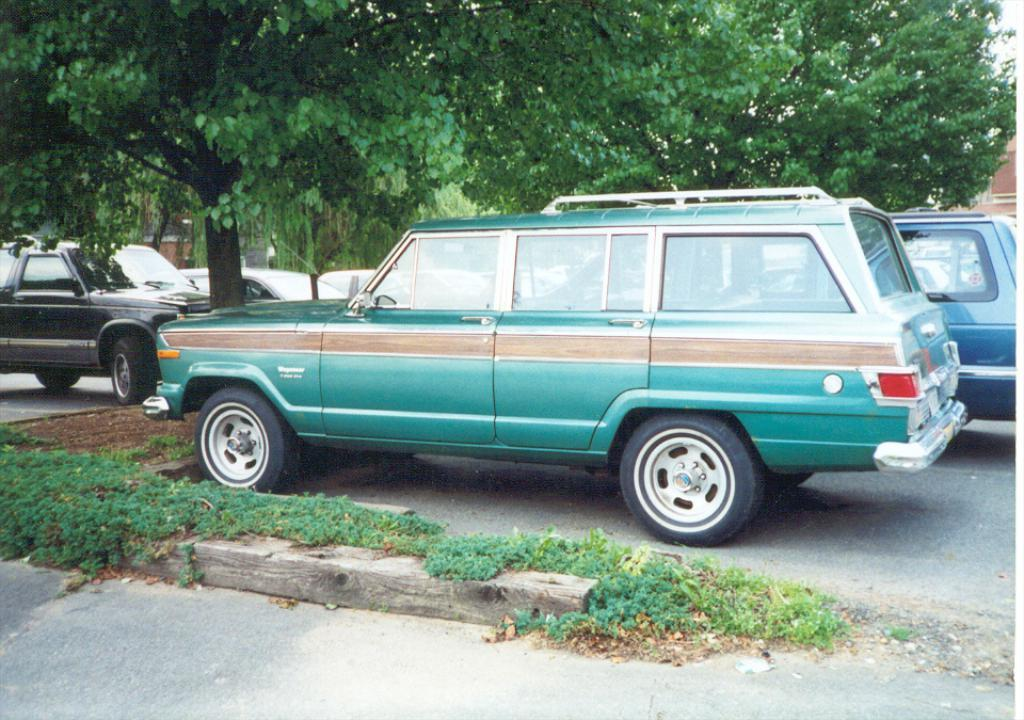What type of vehicles can be seen on the road in the image? There are cars on the road in the image. What can be seen in the background of the image? There are trees and buildings in the background of the image. Can you tell me how many goldfish are swimming in the trees in the image? There are no goldfish present in the image, and goldfish cannot swim in trees. 